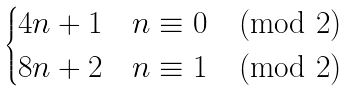Convert formula to latex. <formula><loc_0><loc_0><loc_500><loc_500>\begin{cases} 4 n + 1 & n \equiv 0 \pmod { 2 } \\ 8 n + 2 & n \equiv 1 \pmod { 2 } \end{cases}</formula> 